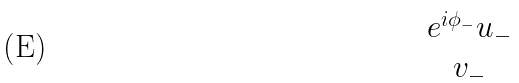Convert formula to latex. <formula><loc_0><loc_0><loc_500><loc_500>\begin{matrix} e ^ { i \phi _ { - } } u _ { - } \\ v _ { - } \end{matrix}</formula> 